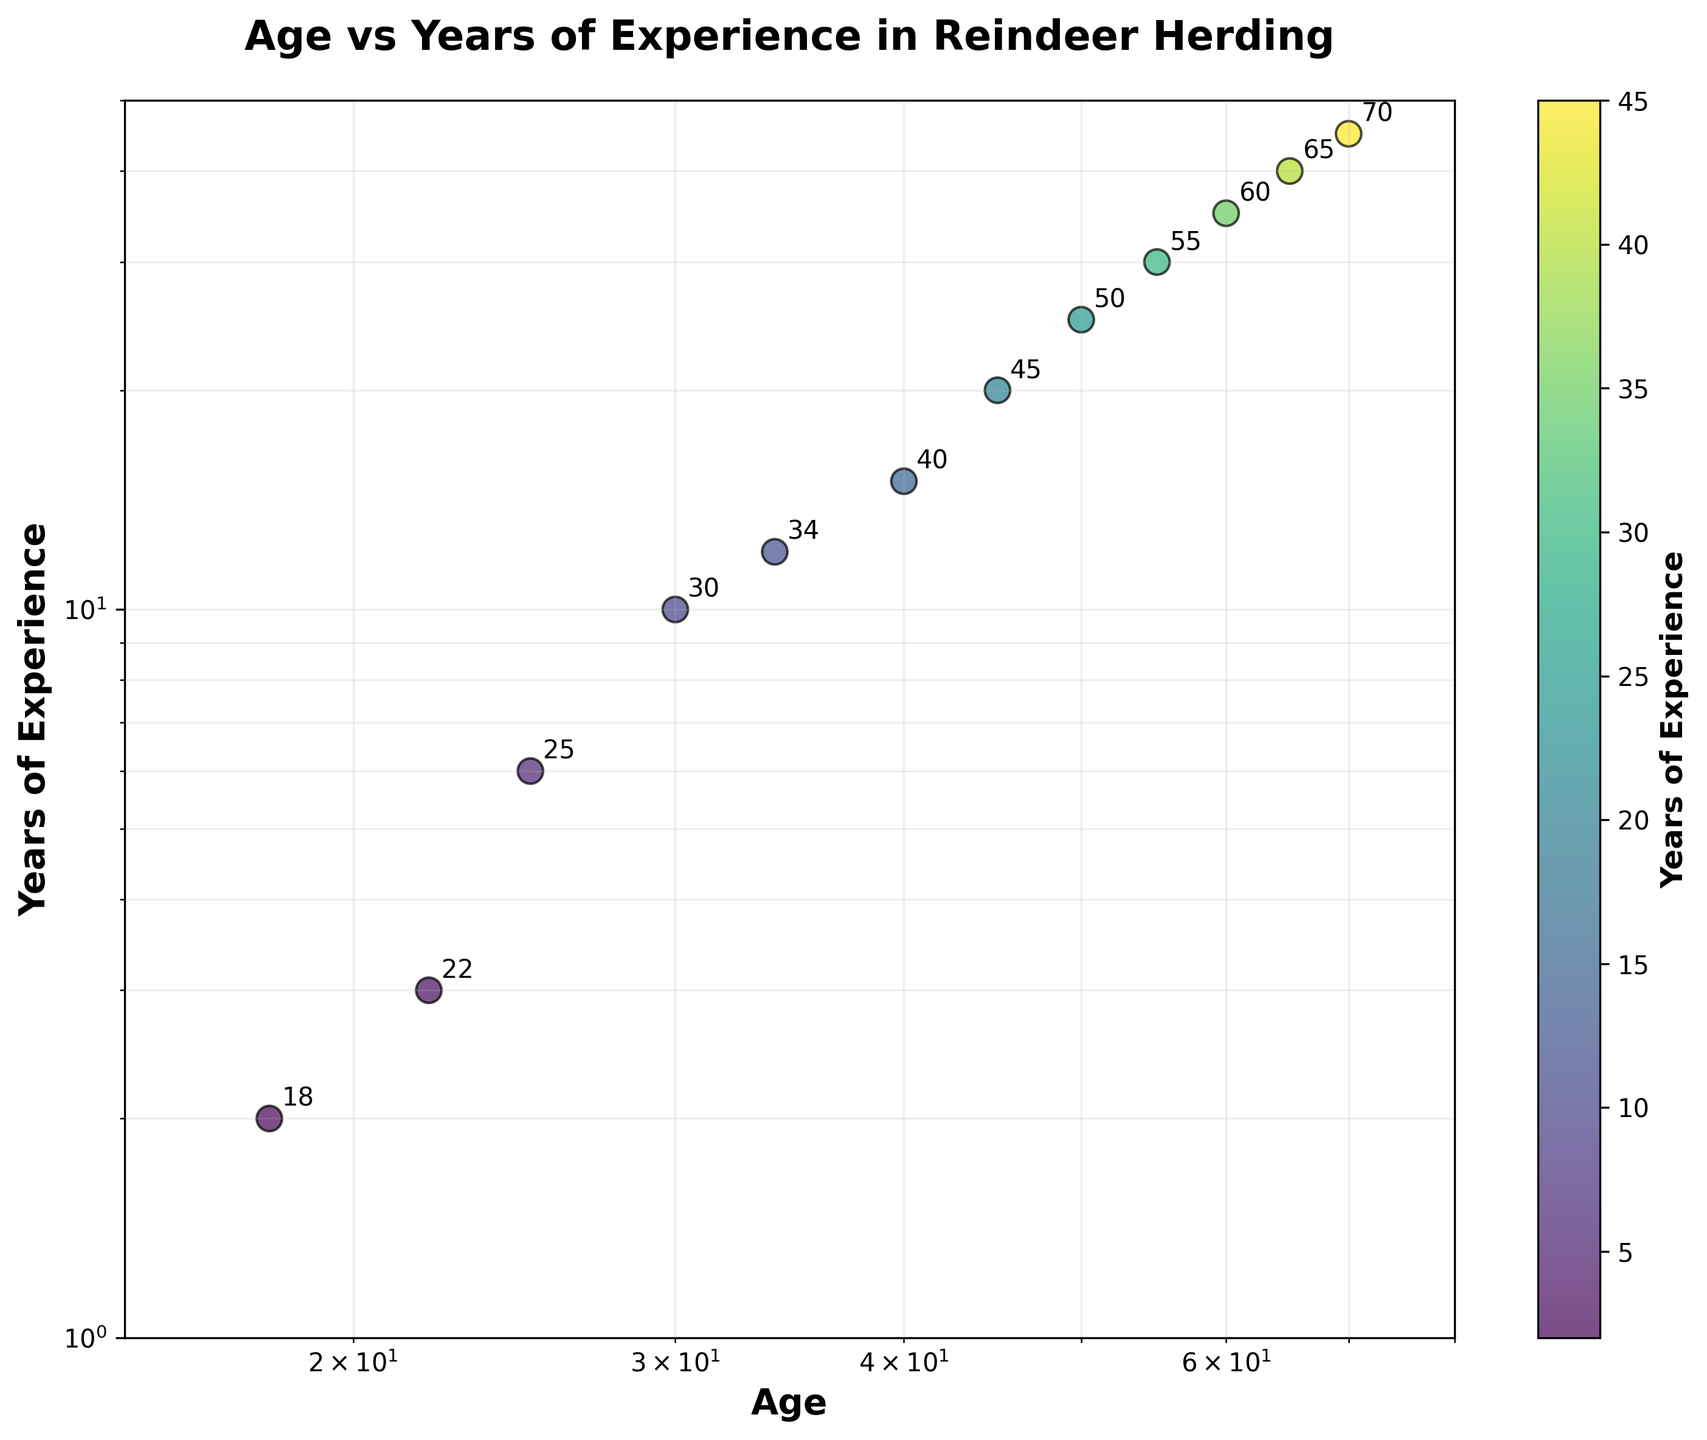what is the title of the plot? The title of the plot is usually placed at the top center of the figure, representing the main idea or the subject of the chart. In this plot, the title is "Age vs Years of Experience in Reindeer Herding."
Answer: Age vs Years of Experience in Reindeer Herding What is the range for the ages plotted on the x-axis? The x-axis shows ages on a logarithmic scale. The range of numbers on the axes starts from 15 to 80.
Answer: 15 to 80 How many data points are plotted in the figure? By looking at the scatter points in the plot, we can count the number of data points representing age and years of experience. There are 12 points.
Answer: 12 Which age has the highest years of experience? By comparing the points on the scatter plot, the point with age 70 has the highest number of years of experience, which is 45 years.
Answer: 70 What color indicates higher years of experience in the plot? The color of the points is determined by the colorbar, where darker shades tend to represent lower values and brighter shades represent higher values, with yellow being the highest.
Answer: Yellow What is the difference in years of experience between the ages of 50 and 60? The plot shows that age 50 has 25 years of experience, and age 60 has 35 years of experience. The difference is 35 - 25 = 10 years.
Answer: 10 years What is the average age for data points with more than 30 years of experience? Examining the plot, the ages with more than 30 years of experience are 60, 65, and 70. The average age is calculated as (60 + 65 + 70) / 3 = 65.
Answer: 65 Between ages 22 and 34, which age has more years of experience? At age 22, the years of experience are 3. At age 34, it is 12. Comparing the two, age 34 has more years of experience.
Answer: 34 What is the median age in the data? Sorting the ages in ascending order: 18, 22, 25, 30, 34, 40, 45, 50, 55, 60, 65, 70. In a list of 12 ages, the median falls between the 6th and 7th values. So, (40+45)/2 = 42.5.
Answer: 42.5 